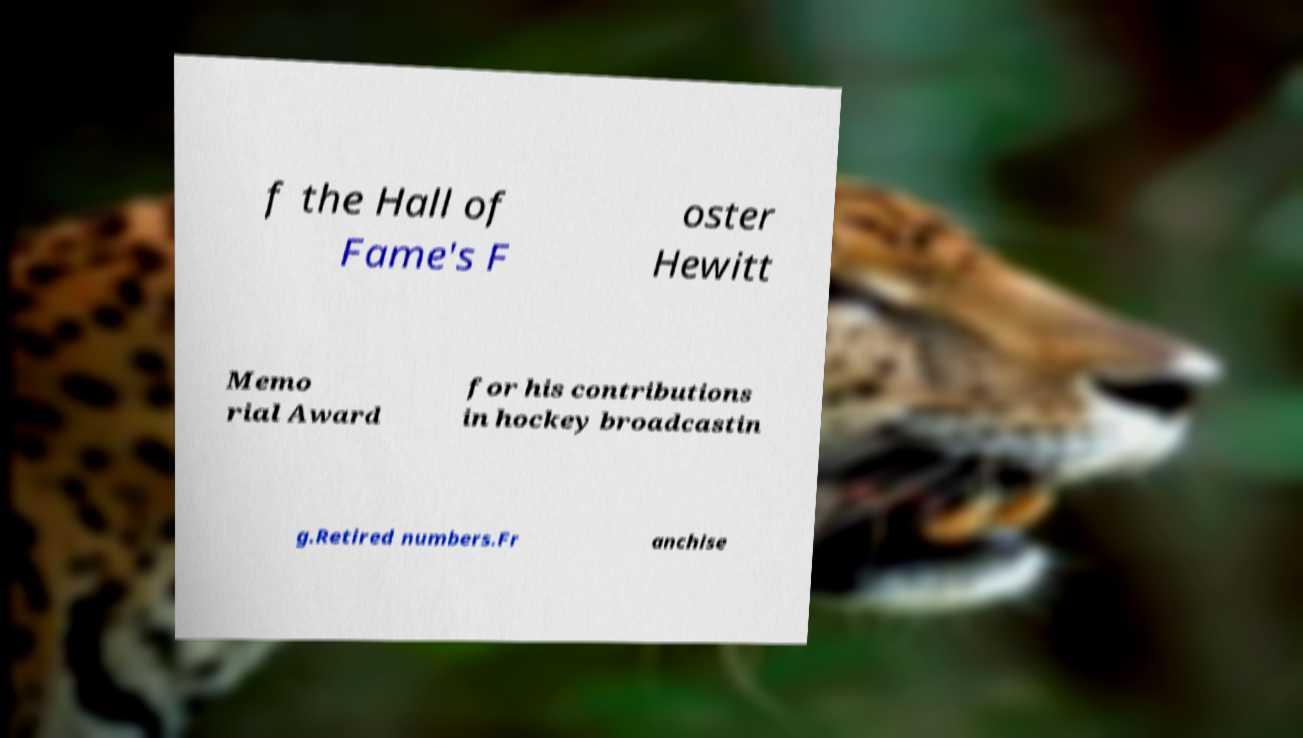Could you assist in decoding the text presented in this image and type it out clearly? f the Hall of Fame's F oster Hewitt Memo rial Award for his contributions in hockey broadcastin g.Retired numbers.Fr anchise 